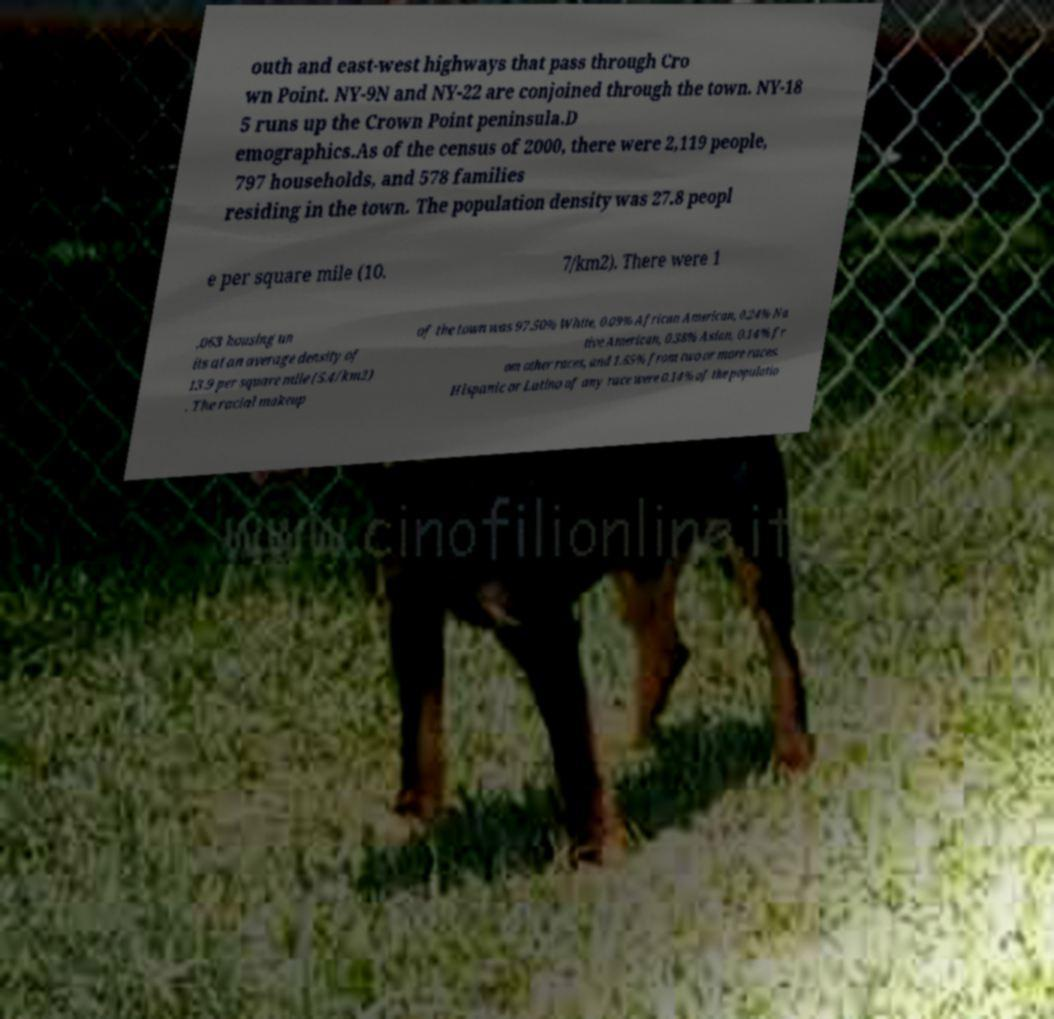Can you read and provide the text displayed in the image?This photo seems to have some interesting text. Can you extract and type it out for me? outh and east-west highways that pass through Cro wn Point. NY-9N and NY-22 are conjoined through the town. NY-18 5 runs up the Crown Point peninsula.D emographics.As of the census of 2000, there were 2,119 people, 797 households, and 578 families residing in the town. The population density was 27.8 peopl e per square mile (10. 7/km2). There were 1 ,063 housing un its at an average density of 13.9 per square mile (5.4/km2) . The racial makeup of the town was 97.50% White, 0.09% African American, 0.24% Na tive American, 0.38% Asian, 0.14% fr om other races, and 1.65% from two or more races. Hispanic or Latino of any race were 0.14% of the populatio 